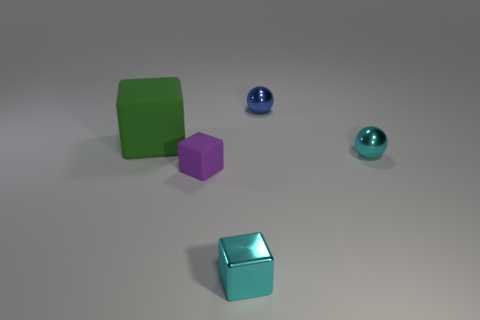Add 1 brown balls. How many objects exist? 6 Subtract all blocks. How many objects are left? 2 Subtract 0 red blocks. How many objects are left? 5 Subtract all blue objects. Subtract all cyan things. How many objects are left? 2 Add 5 tiny blocks. How many tiny blocks are left? 7 Add 5 tiny cubes. How many tiny cubes exist? 7 